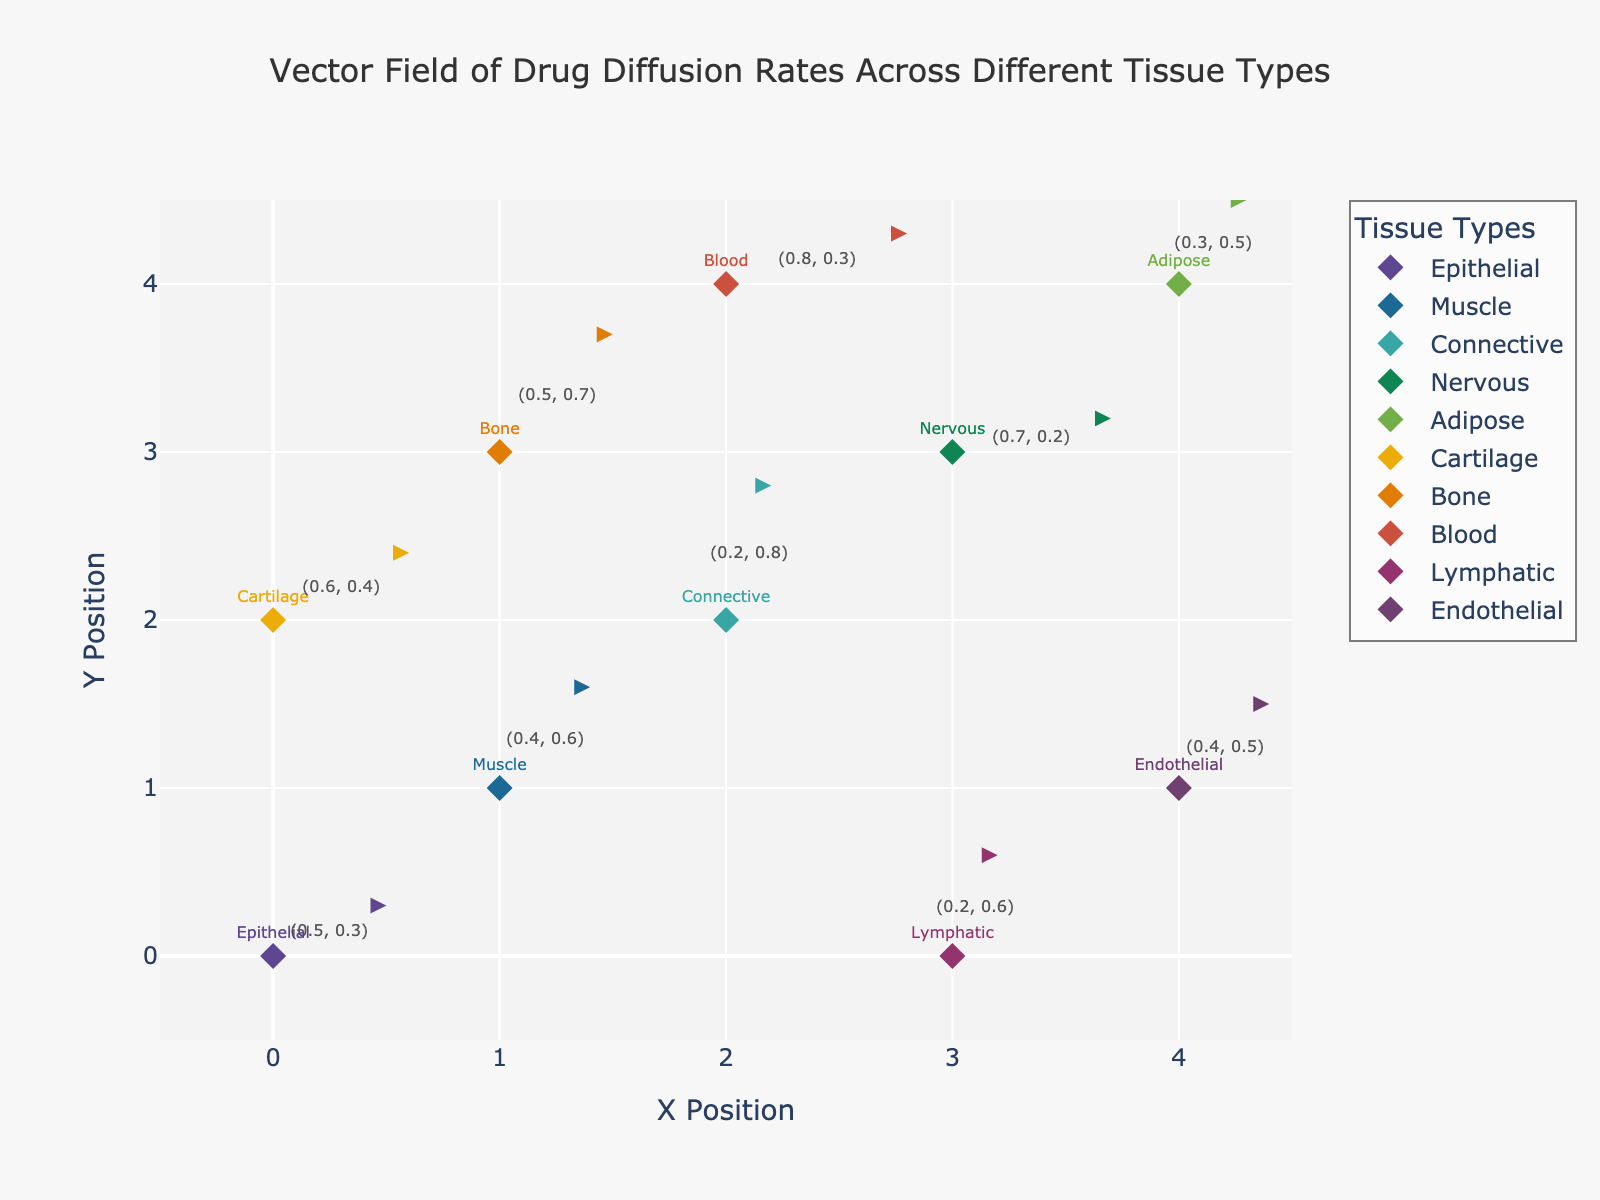What is the title of the plot? The title is displayed at the top of the plot in a prominent font. It is intended to provide a clear and concise description of what the plot represents.
Answer: Vector Field of Drug Diffusion Rates Across Different Tissue Types Which tissue type has a data point at the coordinates (2, 2)? By looking at the data points and their respective labels, the tissue type at coordinates (2, 2) can be identified based on the markers and text annotations.
Answer: Connective How many tissue types are represented in the plot? The plot shows different tissue types each represented by unique markers and colors. Counting these unique markers/labels will give the total number of tissue types.
Answer: 10 Which tissue type has the highest u-component of the diffusion rate? Each tissue's diffusion rates are labeled on the plot. By comparing the u-values (first component) of each tissue type, the highest can be identified. The highest u-value is 0.8 for "Blood".
Answer: Blood What are the diffusion rate components for Cartilage tissue type? By finding the Cartilage tissue point on the plot and looking at the annotation showing the diffusion rate components, the values can be extracted.
Answer: (0.6, 0.4) Where is the Muscle tissue located on the plot? The Muscle tissue's coordinates can be identified by locating the marker labeled as Muscle.
Answer: (1, 1) How is the direction of drug diffusion for Epithelial tissue represented on the plot? For Epithelial tissue, the arrow and vector components visually show the direction by extending from the initial point (0, 0) according to values of u and v. It points toward (0.5, 0.3).
Answer: (0.5, 0.3) Which tissue type shows the least horizontal diffusion rate? By comparing the u-components (horizontal rates) of all tissue types, the smallest value will indicate the least horizontal diffusion rate. Both Nervous and Connective tissues have the smallest u-rate of 0.2.
Answer: Nervous or Connective 